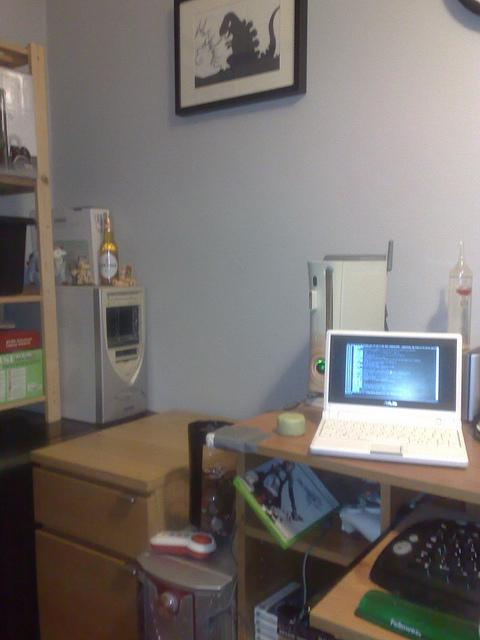What kind of beverage is sat atop of the computer tower in the corner of this room?

Choices:
A) water
B) beer
C) juice
D) wine beer 